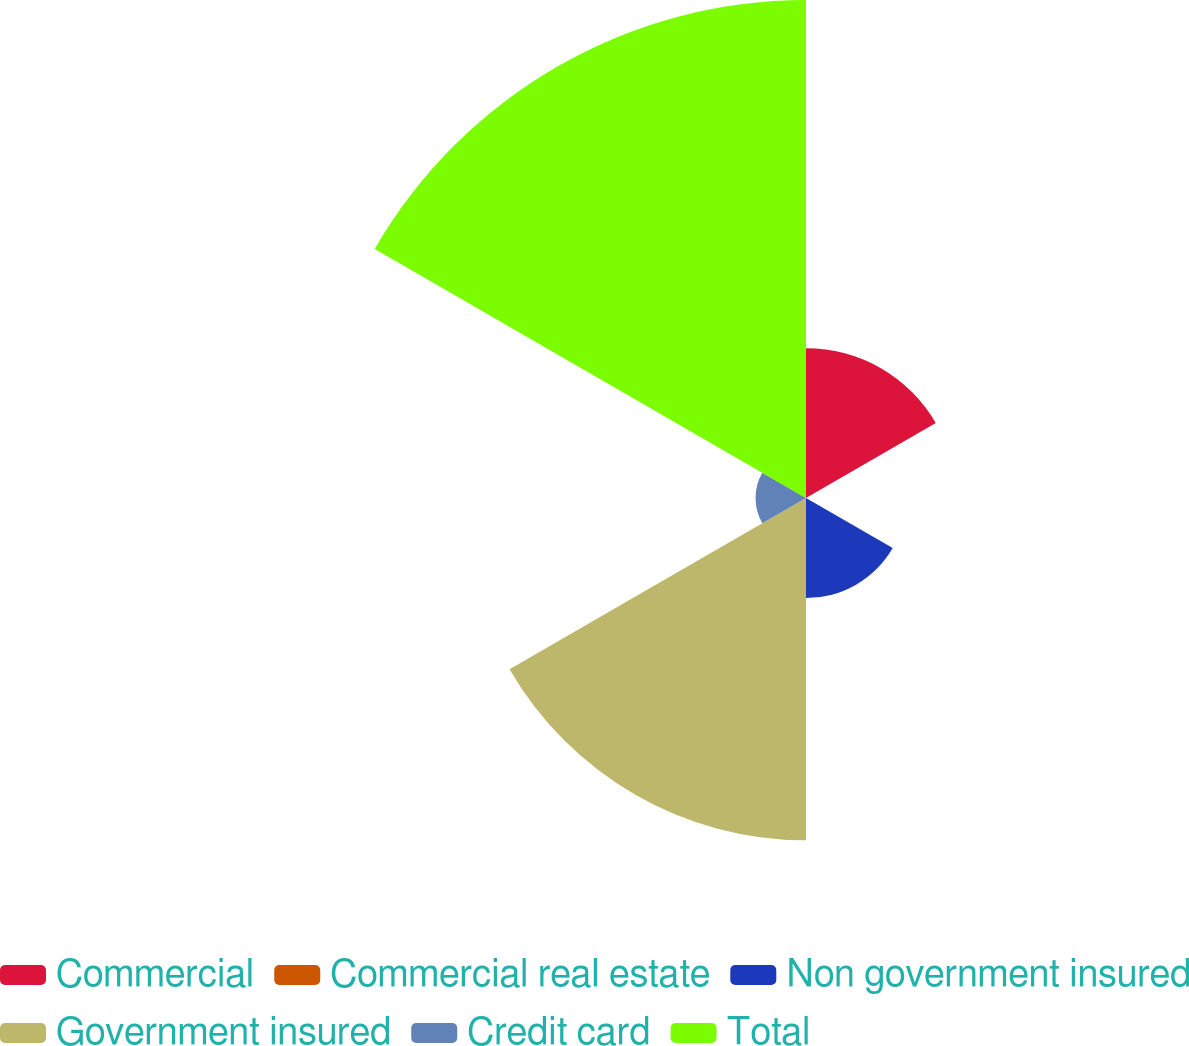Convert chart. <chart><loc_0><loc_0><loc_500><loc_500><pie_chart><fcel>Commercial<fcel>Commercial real estate<fcel>Non government insured<fcel>Government insured<fcel>Credit card<fcel>Total<nl><fcel>13.13%<fcel>0.06%<fcel>8.77%<fcel>29.99%<fcel>4.42%<fcel>43.63%<nl></chart> 